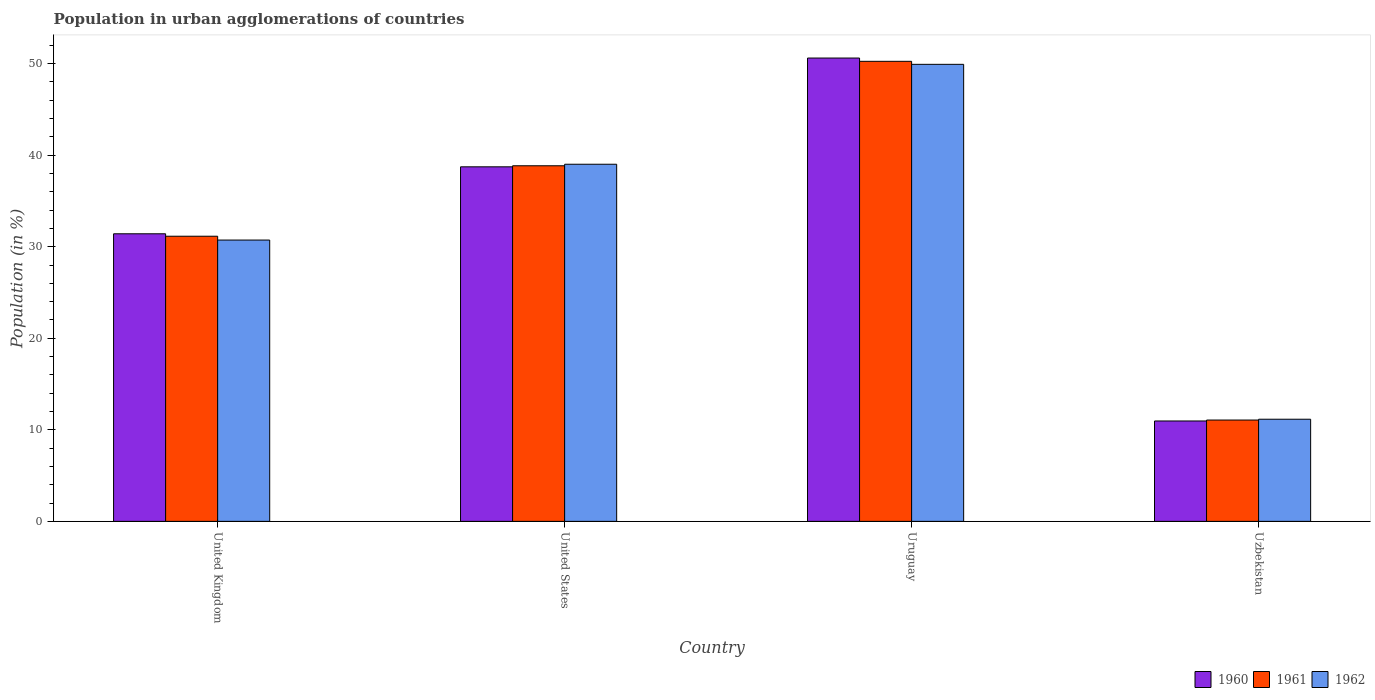How many different coloured bars are there?
Your response must be concise. 3. Are the number of bars per tick equal to the number of legend labels?
Keep it short and to the point. Yes. How many bars are there on the 4th tick from the left?
Give a very brief answer. 3. What is the label of the 3rd group of bars from the left?
Keep it short and to the point. Uruguay. What is the percentage of population in urban agglomerations in 1960 in United Kingdom?
Your answer should be very brief. 31.42. Across all countries, what is the maximum percentage of population in urban agglomerations in 1961?
Make the answer very short. 50.26. Across all countries, what is the minimum percentage of population in urban agglomerations in 1960?
Your answer should be very brief. 10.97. In which country was the percentage of population in urban agglomerations in 1960 maximum?
Provide a succinct answer. Uruguay. In which country was the percentage of population in urban agglomerations in 1961 minimum?
Provide a succinct answer. Uzbekistan. What is the total percentage of population in urban agglomerations in 1962 in the graph?
Give a very brief answer. 130.83. What is the difference between the percentage of population in urban agglomerations in 1961 in United Kingdom and that in United States?
Your answer should be very brief. -7.7. What is the difference between the percentage of population in urban agglomerations in 1960 in Uruguay and the percentage of population in urban agglomerations in 1961 in United States?
Offer a terse response. 11.77. What is the average percentage of population in urban agglomerations in 1962 per country?
Your response must be concise. 32.71. What is the difference between the percentage of population in urban agglomerations of/in 1962 and percentage of population in urban agglomerations of/in 1961 in Uruguay?
Offer a terse response. -0.33. In how many countries, is the percentage of population in urban agglomerations in 1962 greater than 46 %?
Provide a succinct answer. 1. What is the ratio of the percentage of population in urban agglomerations in 1960 in United States to that in Uruguay?
Ensure brevity in your answer.  0.77. What is the difference between the highest and the second highest percentage of population in urban agglomerations in 1960?
Make the answer very short. 11.88. What is the difference between the highest and the lowest percentage of population in urban agglomerations in 1960?
Provide a succinct answer. 39.65. What does the 3rd bar from the left in United States represents?
Give a very brief answer. 1962. What does the 3rd bar from the right in United Kingdom represents?
Provide a short and direct response. 1960. How many bars are there?
Make the answer very short. 12. What is the difference between two consecutive major ticks on the Y-axis?
Give a very brief answer. 10. Are the values on the major ticks of Y-axis written in scientific E-notation?
Keep it short and to the point. No. Does the graph contain any zero values?
Ensure brevity in your answer.  No. Does the graph contain grids?
Your response must be concise. No. How many legend labels are there?
Your answer should be compact. 3. How are the legend labels stacked?
Your response must be concise. Horizontal. What is the title of the graph?
Ensure brevity in your answer.  Population in urban agglomerations of countries. Does "1989" appear as one of the legend labels in the graph?
Your answer should be very brief. No. What is the label or title of the X-axis?
Provide a succinct answer. Country. What is the label or title of the Y-axis?
Your response must be concise. Population (in %). What is the Population (in %) in 1960 in United Kingdom?
Offer a terse response. 31.42. What is the Population (in %) of 1961 in United Kingdom?
Provide a short and direct response. 31.15. What is the Population (in %) in 1962 in United Kingdom?
Your answer should be compact. 30.73. What is the Population (in %) of 1960 in United States?
Provide a short and direct response. 38.73. What is the Population (in %) in 1961 in United States?
Make the answer very short. 38.85. What is the Population (in %) of 1962 in United States?
Your response must be concise. 39.01. What is the Population (in %) of 1960 in Uruguay?
Your response must be concise. 50.62. What is the Population (in %) in 1961 in Uruguay?
Keep it short and to the point. 50.26. What is the Population (in %) in 1962 in Uruguay?
Your answer should be very brief. 49.93. What is the Population (in %) of 1960 in Uzbekistan?
Keep it short and to the point. 10.97. What is the Population (in %) of 1961 in Uzbekistan?
Provide a succinct answer. 11.07. What is the Population (in %) of 1962 in Uzbekistan?
Make the answer very short. 11.16. Across all countries, what is the maximum Population (in %) of 1960?
Ensure brevity in your answer.  50.62. Across all countries, what is the maximum Population (in %) in 1961?
Offer a very short reply. 50.26. Across all countries, what is the maximum Population (in %) of 1962?
Provide a succinct answer. 49.93. Across all countries, what is the minimum Population (in %) of 1960?
Make the answer very short. 10.97. Across all countries, what is the minimum Population (in %) in 1961?
Make the answer very short. 11.07. Across all countries, what is the minimum Population (in %) in 1962?
Offer a very short reply. 11.16. What is the total Population (in %) in 1960 in the graph?
Provide a succinct answer. 131.73. What is the total Population (in %) of 1961 in the graph?
Your response must be concise. 131.32. What is the total Population (in %) of 1962 in the graph?
Your answer should be compact. 130.83. What is the difference between the Population (in %) of 1960 in United Kingdom and that in United States?
Provide a succinct answer. -7.32. What is the difference between the Population (in %) of 1961 in United Kingdom and that in United States?
Give a very brief answer. -7.7. What is the difference between the Population (in %) in 1962 in United Kingdom and that in United States?
Provide a succinct answer. -8.28. What is the difference between the Population (in %) in 1960 in United Kingdom and that in Uruguay?
Your answer should be compact. -19.2. What is the difference between the Population (in %) in 1961 in United Kingdom and that in Uruguay?
Your response must be concise. -19.11. What is the difference between the Population (in %) in 1962 in United Kingdom and that in Uruguay?
Give a very brief answer. -19.2. What is the difference between the Population (in %) of 1960 in United Kingdom and that in Uzbekistan?
Offer a very short reply. 20.45. What is the difference between the Population (in %) of 1961 in United Kingdom and that in Uzbekistan?
Keep it short and to the point. 20.08. What is the difference between the Population (in %) in 1962 in United Kingdom and that in Uzbekistan?
Your answer should be compact. 19.57. What is the difference between the Population (in %) of 1960 in United States and that in Uruguay?
Provide a short and direct response. -11.88. What is the difference between the Population (in %) in 1961 in United States and that in Uruguay?
Ensure brevity in your answer.  -11.41. What is the difference between the Population (in %) of 1962 in United States and that in Uruguay?
Offer a terse response. -10.91. What is the difference between the Population (in %) in 1960 in United States and that in Uzbekistan?
Offer a very short reply. 27.77. What is the difference between the Population (in %) in 1961 in United States and that in Uzbekistan?
Offer a terse response. 27.78. What is the difference between the Population (in %) in 1962 in United States and that in Uzbekistan?
Provide a succinct answer. 27.85. What is the difference between the Population (in %) in 1960 in Uruguay and that in Uzbekistan?
Keep it short and to the point. 39.65. What is the difference between the Population (in %) of 1961 in Uruguay and that in Uzbekistan?
Give a very brief answer. 39.19. What is the difference between the Population (in %) in 1962 in Uruguay and that in Uzbekistan?
Your answer should be compact. 38.77. What is the difference between the Population (in %) in 1960 in United Kingdom and the Population (in %) in 1961 in United States?
Offer a terse response. -7.43. What is the difference between the Population (in %) of 1960 in United Kingdom and the Population (in %) of 1962 in United States?
Give a very brief answer. -7.6. What is the difference between the Population (in %) of 1961 in United Kingdom and the Population (in %) of 1962 in United States?
Your response must be concise. -7.86. What is the difference between the Population (in %) of 1960 in United Kingdom and the Population (in %) of 1961 in Uruguay?
Your response must be concise. -18.84. What is the difference between the Population (in %) in 1960 in United Kingdom and the Population (in %) in 1962 in Uruguay?
Provide a succinct answer. -18.51. What is the difference between the Population (in %) in 1961 in United Kingdom and the Population (in %) in 1962 in Uruguay?
Keep it short and to the point. -18.78. What is the difference between the Population (in %) in 1960 in United Kingdom and the Population (in %) in 1961 in Uzbekistan?
Make the answer very short. 20.35. What is the difference between the Population (in %) of 1960 in United Kingdom and the Population (in %) of 1962 in Uzbekistan?
Provide a short and direct response. 20.26. What is the difference between the Population (in %) in 1961 in United Kingdom and the Population (in %) in 1962 in Uzbekistan?
Your answer should be very brief. 19.99. What is the difference between the Population (in %) in 1960 in United States and the Population (in %) in 1961 in Uruguay?
Make the answer very short. -11.53. What is the difference between the Population (in %) in 1960 in United States and the Population (in %) in 1962 in Uruguay?
Your response must be concise. -11.2. What is the difference between the Population (in %) in 1961 in United States and the Population (in %) in 1962 in Uruguay?
Your response must be concise. -11.08. What is the difference between the Population (in %) of 1960 in United States and the Population (in %) of 1961 in Uzbekistan?
Your answer should be compact. 27.66. What is the difference between the Population (in %) in 1960 in United States and the Population (in %) in 1962 in Uzbekistan?
Keep it short and to the point. 27.57. What is the difference between the Population (in %) of 1961 in United States and the Population (in %) of 1962 in Uzbekistan?
Make the answer very short. 27.69. What is the difference between the Population (in %) of 1960 in Uruguay and the Population (in %) of 1961 in Uzbekistan?
Offer a terse response. 39.55. What is the difference between the Population (in %) in 1960 in Uruguay and the Population (in %) in 1962 in Uzbekistan?
Your answer should be very brief. 39.46. What is the difference between the Population (in %) in 1961 in Uruguay and the Population (in %) in 1962 in Uzbekistan?
Provide a succinct answer. 39.1. What is the average Population (in %) of 1960 per country?
Provide a succinct answer. 32.93. What is the average Population (in %) in 1961 per country?
Your answer should be very brief. 32.83. What is the average Population (in %) in 1962 per country?
Provide a short and direct response. 32.71. What is the difference between the Population (in %) of 1960 and Population (in %) of 1961 in United Kingdom?
Your response must be concise. 0.27. What is the difference between the Population (in %) in 1960 and Population (in %) in 1962 in United Kingdom?
Ensure brevity in your answer.  0.68. What is the difference between the Population (in %) of 1961 and Population (in %) of 1962 in United Kingdom?
Ensure brevity in your answer.  0.42. What is the difference between the Population (in %) of 1960 and Population (in %) of 1961 in United States?
Make the answer very short. -0.11. What is the difference between the Population (in %) of 1960 and Population (in %) of 1962 in United States?
Your answer should be very brief. -0.28. What is the difference between the Population (in %) of 1961 and Population (in %) of 1962 in United States?
Provide a succinct answer. -0.17. What is the difference between the Population (in %) of 1960 and Population (in %) of 1961 in Uruguay?
Your response must be concise. 0.36. What is the difference between the Population (in %) in 1960 and Population (in %) in 1962 in Uruguay?
Make the answer very short. 0.69. What is the difference between the Population (in %) in 1961 and Population (in %) in 1962 in Uruguay?
Provide a succinct answer. 0.33. What is the difference between the Population (in %) in 1960 and Population (in %) in 1961 in Uzbekistan?
Make the answer very short. -0.1. What is the difference between the Population (in %) in 1960 and Population (in %) in 1962 in Uzbekistan?
Make the answer very short. -0.19. What is the difference between the Population (in %) in 1961 and Population (in %) in 1962 in Uzbekistan?
Give a very brief answer. -0.09. What is the ratio of the Population (in %) of 1960 in United Kingdom to that in United States?
Make the answer very short. 0.81. What is the ratio of the Population (in %) in 1961 in United Kingdom to that in United States?
Your answer should be very brief. 0.8. What is the ratio of the Population (in %) in 1962 in United Kingdom to that in United States?
Provide a short and direct response. 0.79. What is the ratio of the Population (in %) in 1960 in United Kingdom to that in Uruguay?
Provide a succinct answer. 0.62. What is the ratio of the Population (in %) of 1961 in United Kingdom to that in Uruguay?
Keep it short and to the point. 0.62. What is the ratio of the Population (in %) in 1962 in United Kingdom to that in Uruguay?
Provide a succinct answer. 0.62. What is the ratio of the Population (in %) in 1960 in United Kingdom to that in Uzbekistan?
Keep it short and to the point. 2.86. What is the ratio of the Population (in %) of 1961 in United Kingdom to that in Uzbekistan?
Keep it short and to the point. 2.81. What is the ratio of the Population (in %) of 1962 in United Kingdom to that in Uzbekistan?
Offer a very short reply. 2.75. What is the ratio of the Population (in %) of 1960 in United States to that in Uruguay?
Give a very brief answer. 0.77. What is the ratio of the Population (in %) in 1961 in United States to that in Uruguay?
Offer a very short reply. 0.77. What is the ratio of the Population (in %) in 1962 in United States to that in Uruguay?
Provide a succinct answer. 0.78. What is the ratio of the Population (in %) in 1960 in United States to that in Uzbekistan?
Keep it short and to the point. 3.53. What is the ratio of the Population (in %) in 1961 in United States to that in Uzbekistan?
Ensure brevity in your answer.  3.51. What is the ratio of the Population (in %) of 1962 in United States to that in Uzbekistan?
Provide a succinct answer. 3.5. What is the ratio of the Population (in %) in 1960 in Uruguay to that in Uzbekistan?
Make the answer very short. 4.62. What is the ratio of the Population (in %) in 1961 in Uruguay to that in Uzbekistan?
Your answer should be very brief. 4.54. What is the ratio of the Population (in %) of 1962 in Uruguay to that in Uzbekistan?
Offer a terse response. 4.47. What is the difference between the highest and the second highest Population (in %) of 1960?
Make the answer very short. 11.88. What is the difference between the highest and the second highest Population (in %) in 1961?
Provide a short and direct response. 11.41. What is the difference between the highest and the second highest Population (in %) of 1962?
Provide a short and direct response. 10.91. What is the difference between the highest and the lowest Population (in %) in 1960?
Provide a short and direct response. 39.65. What is the difference between the highest and the lowest Population (in %) of 1961?
Your answer should be compact. 39.19. What is the difference between the highest and the lowest Population (in %) of 1962?
Keep it short and to the point. 38.77. 